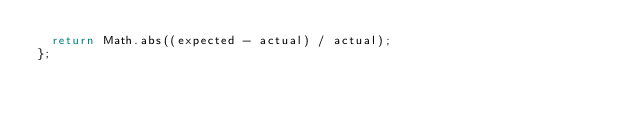Convert code to text. <code><loc_0><loc_0><loc_500><loc_500><_JavaScript_>  return Math.abs((expected - actual) / actual);
};
</code> 